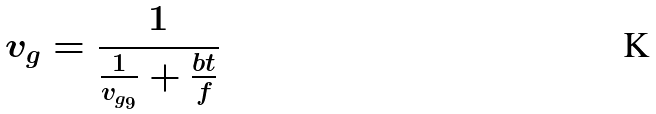<formula> <loc_0><loc_0><loc_500><loc_500>v _ { g } = \frac { 1 } { \frac { 1 } { v _ { g _ { 9 } } } + \frac { b t } { f } }</formula> 